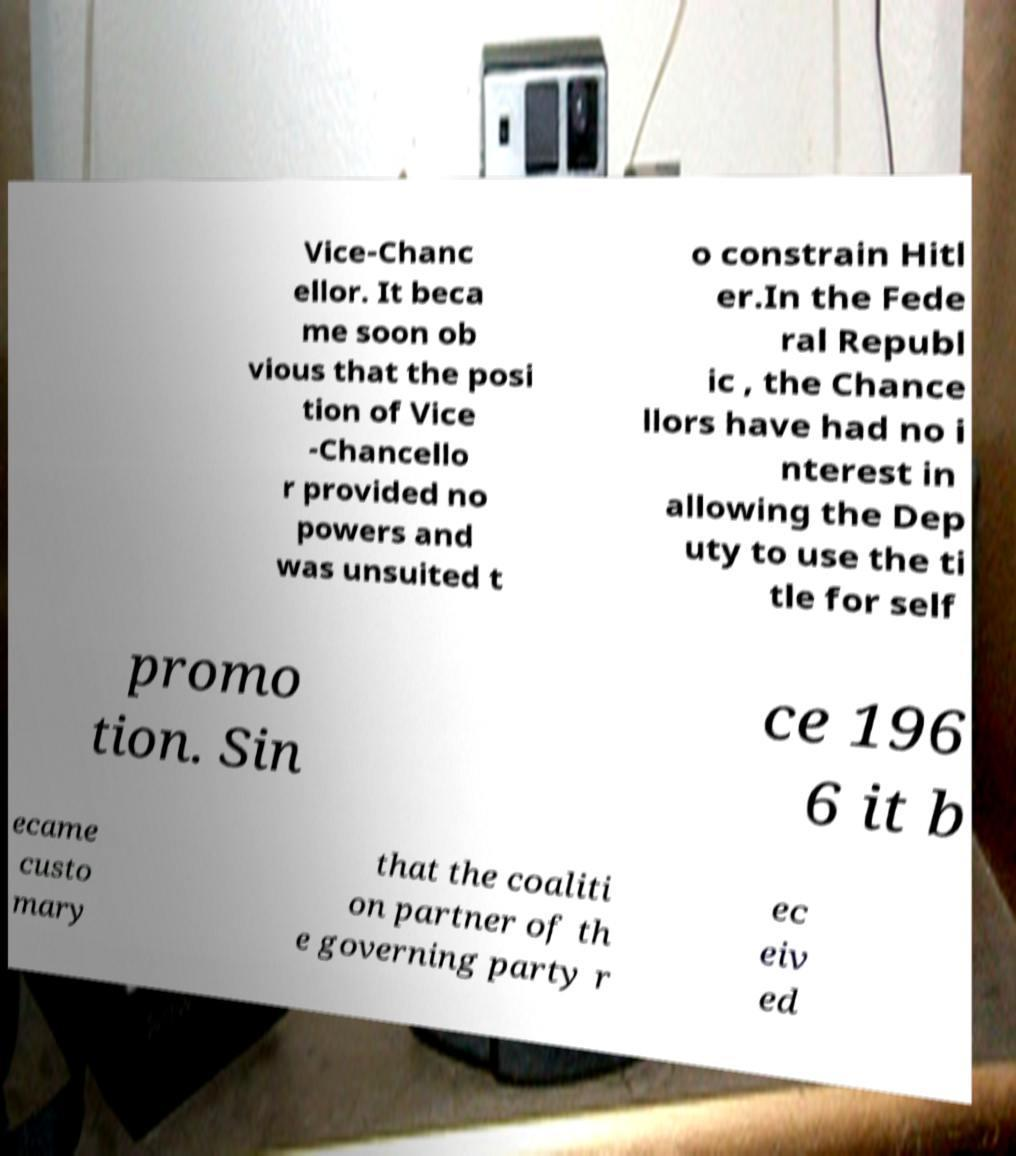Could you extract and type out the text from this image? Vice-Chanc ellor. It beca me soon ob vious that the posi tion of Vice -Chancello r provided no powers and was unsuited t o constrain Hitl er.In the Fede ral Republ ic , the Chance llors have had no i nterest in allowing the Dep uty to use the ti tle for self promo tion. Sin ce 196 6 it b ecame custo mary that the coaliti on partner of th e governing party r ec eiv ed 